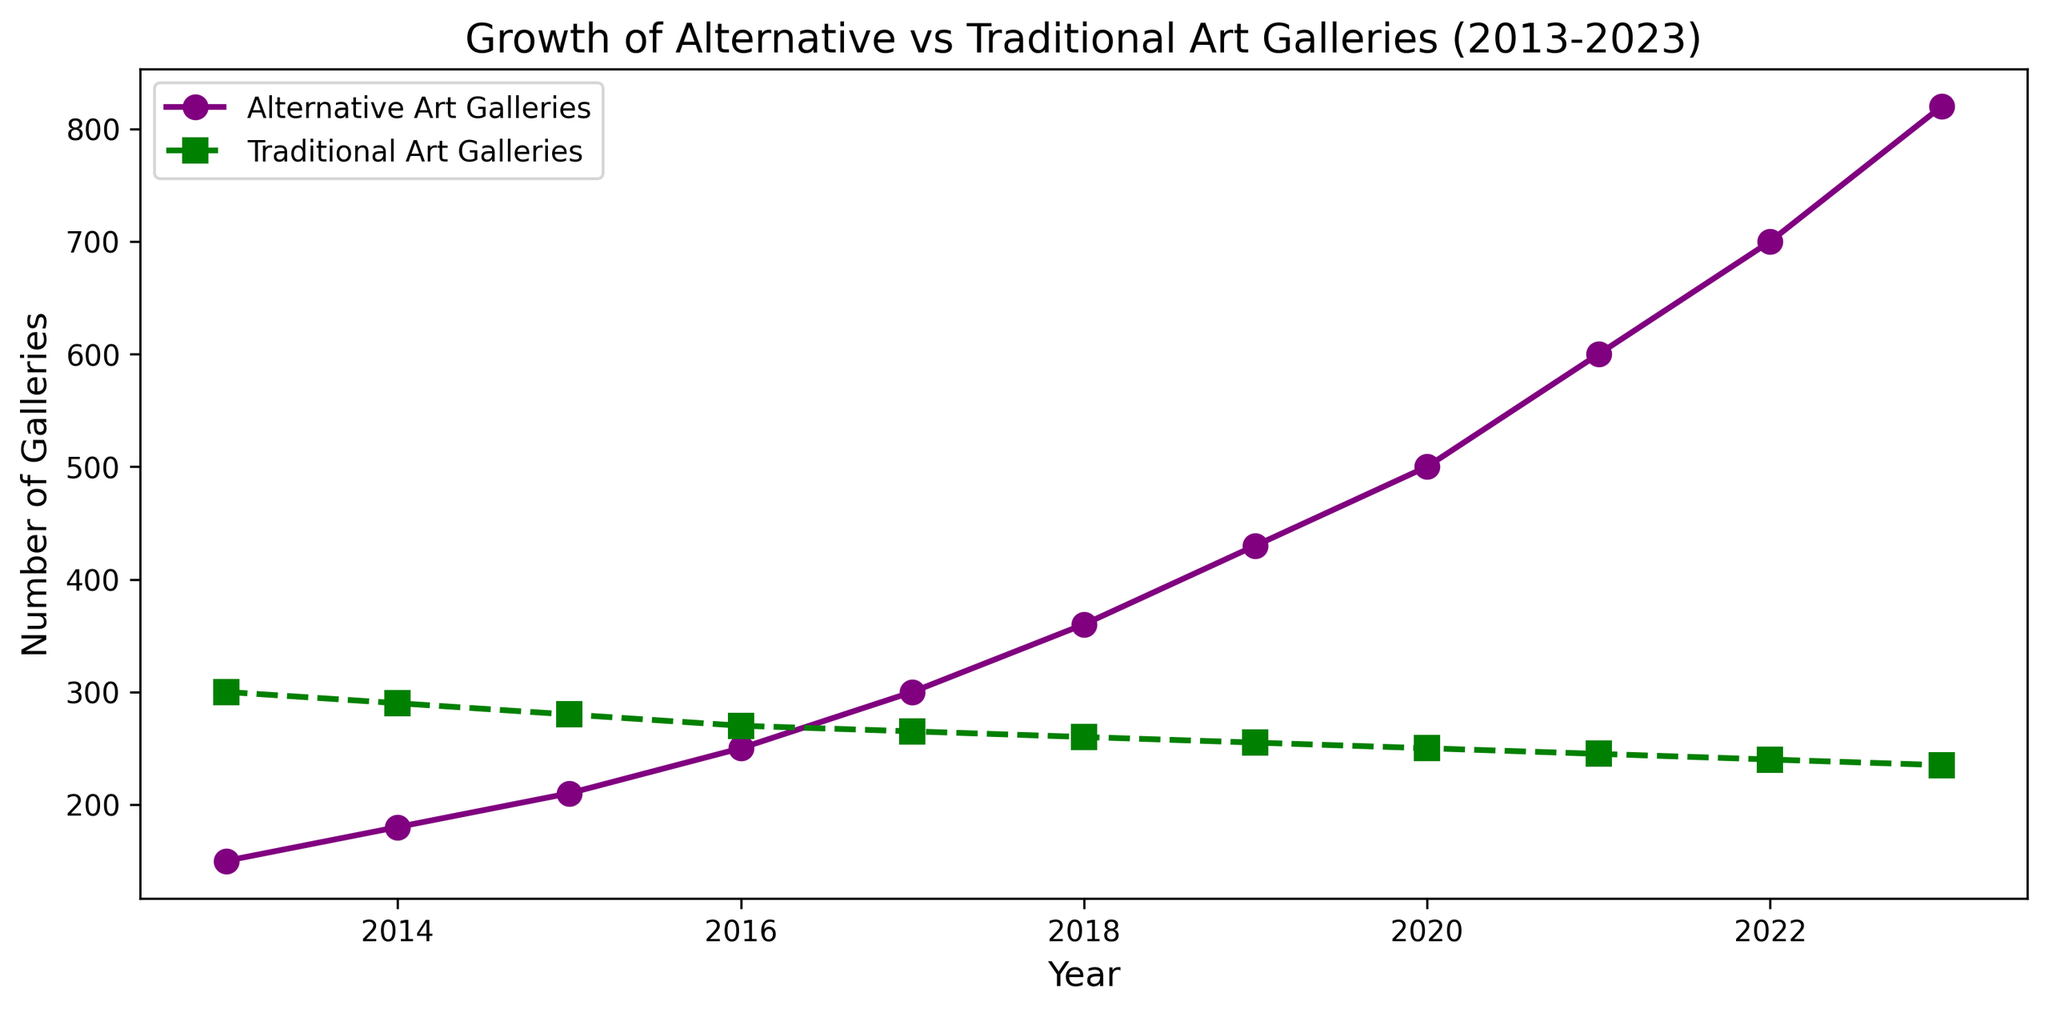What is the number of Alternative Art Galleries in 2020? Look at the data point corresponding to the year 2020 on the line representing Alternative Art Galleries, which is plotted in purple with circular markers.
Answer: 500 How does the number of Traditional Art Galleries in 2023 compare to the number in 2013? Locate the data points for Traditional Art Galleries in the years 2013 and 2023. The number in 2013 is 300 whereas in 2023 it has decreased to 235.
Answer: Decreased Which type of gallery shows a continuous increase in the number over the last decade? Observe the trends for both lines. The Alternative Art Galleries line, plotted in purple, shows a continuous increase, while the Traditional Art Galleries line, plotted in green, shows a decrease.
Answer: Alternative Art Galleries What is the difference between the number of Alternative Art Galleries and Traditional Art Galleries in 2021? Identify the data points for both Alternative (600) and Traditional (245) Art Galleries in 2021, then compute the difference: 600 - 245.
Answer: 355 During which year did the number of Alternative Art Galleries surpass the number of Traditional Art Galleries? Review the trends of both lines. The Alternative Art Galleries line surpasses the Traditional Art Galleries line around the year 2018.
Answer: 2018 How many total galleries (both types combined) were there in 2017? Add the number of Alternative (300) and Traditional Art Galleries (265) in 2017: 300 + 265.
Answer: 565 From 2018 to 2023, what is the average number of Alternative Art Galleries? Sum the values of Alternative Art Galleries from 2018 to 2023 (360 + 430 + 500 + 600 + 700 + 820) and divide by the number of years (6). (360 + 430 + 500 + 600 + 700 + 820) / 6 = 568.33
Answer: 568.33 How much has the number of Traditional Art Galleries decreased from 2013 to 2023? Subtract the number of Traditional Art Galleries in 2023 (235) from the number in 2013 (300): 300 - 235.
Answer: 65 Which year had the highest growth in the number of Alternative Art Galleries compared to the previous year? Calculate the differences in the number of Alternative Art Galleries between consecutive years and identify the highest: (2023-2022), 120 (highest).
Answer: 2023 